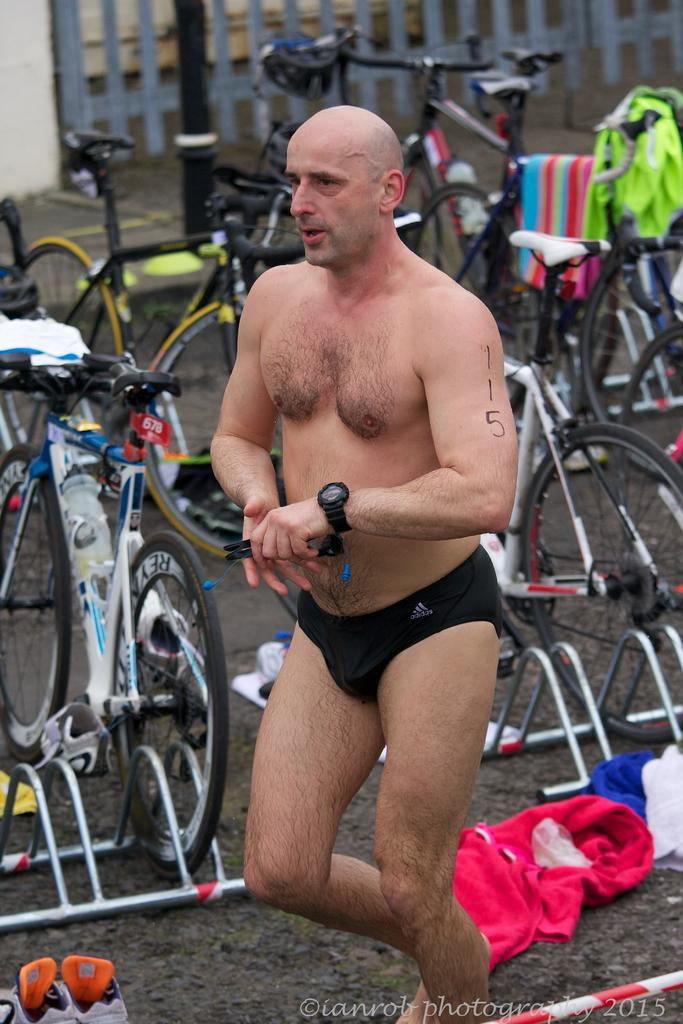What is the main subject of the image? There is a person standing in the image. What can be seen in the background of the image? There are bicycles in the background of the image. What is on the bicycles? There are clothes on the bicycles. Where is the playground located in the image? There is no playground present in the image. What type of boat can be seen in the image? There is no boat present in the image. 